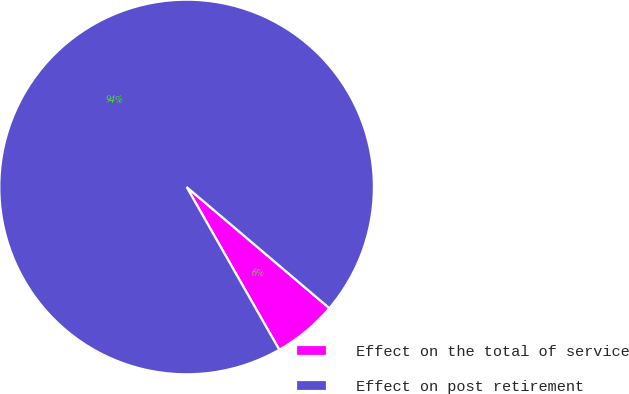<chart> <loc_0><loc_0><loc_500><loc_500><pie_chart><fcel>Effect on the total of service<fcel>Effect on post retirement<nl><fcel>5.56%<fcel>94.44%<nl></chart> 